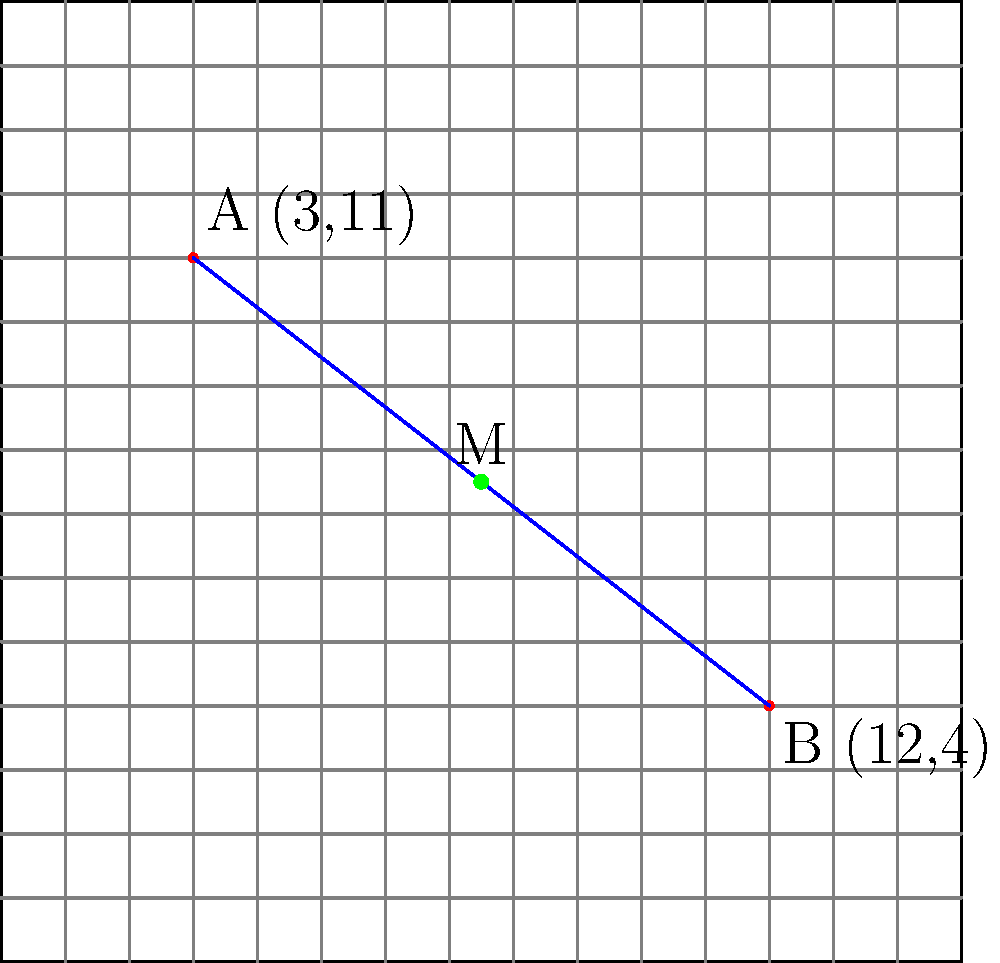On a Scrabble board represented by a coordinate system, two high-value letter positions are located at A(3,11) and B(12,4). Find the coordinates of the midpoint M between these two positions. How might knowing this midpoint help a Scrabble player strategize their gameplay? To find the midpoint M between two points A(x₁,y₁) and B(x₂,y₂), we use the midpoint formula:

$$ M = (\frac{x_1 + x_2}{2}, \frac{y_1 + y_2}{2}) $$

Given:
A(3,11) and B(12,4)

Step 1: Calculate the x-coordinate of the midpoint:
$$ x_M = \frac{x_1 + x_2}{2} = \frac{3 + 12}{2} = \frac{15}{2} = 7.5 $$

Step 2: Calculate the y-coordinate of the midpoint:
$$ y_M = \frac{y_1 + y_2}{2} = \frac{11 + 4}{2} = \frac{15}{2} = 7.5 $$

Therefore, the midpoint M has coordinates (7.5, 7.5).

Knowing this midpoint can help a Scrabble player strategize their gameplay in several ways:

1. It provides a central point to aim for when planning word placements, potentially allowing access to both high-value letter positions.
2. It helps in visualizing the optimal path between the two high-value positions, which could guide the player in creating longer words or setting up future plays.
3. The player can use this information to block opponents from easily connecting these high-value positions.
4. Understanding the midpoint can assist in calculating distances to other important board locations, such as triple word scores or double letter scores.
Answer: M(7.5, 7.5) 